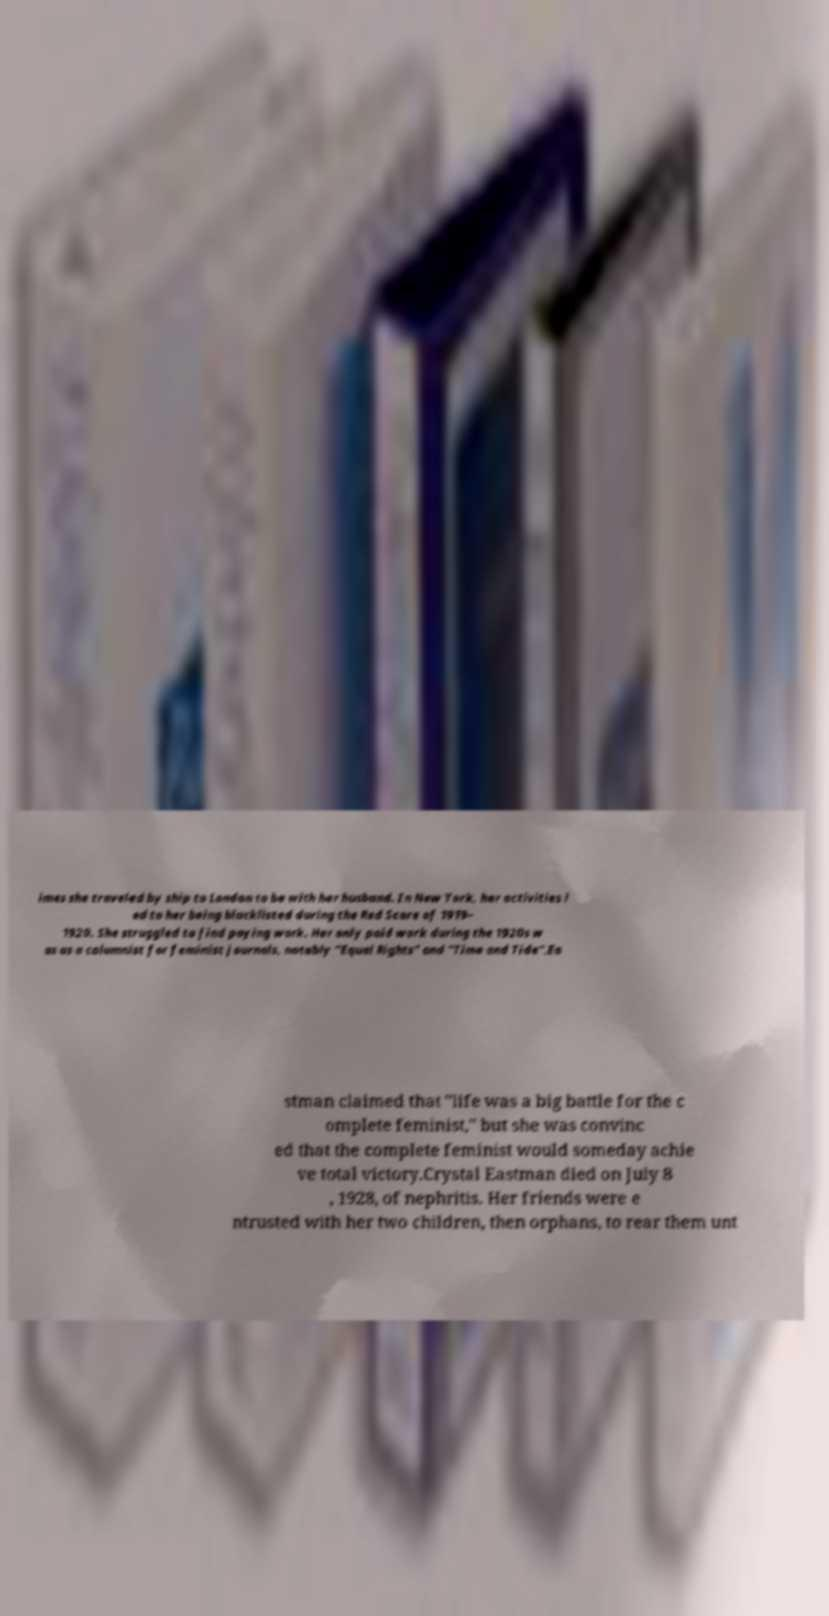For documentation purposes, I need the text within this image transcribed. Could you provide that? imes she traveled by ship to London to be with her husband. In New York, her activities l ed to her being blacklisted during the Red Scare of 1919– 1920. She struggled to find paying work. Her only paid work during the 1920s w as as a columnist for feminist journals, notably "Equal Rights" and "Time and Tide".Ea stman claimed that "life was a big battle for the c omplete feminist," but she was convinc ed that the complete feminist would someday achie ve total victory.Crystal Eastman died on July 8 , 1928, of nephritis. Her friends were e ntrusted with her two children, then orphans, to rear them unt 